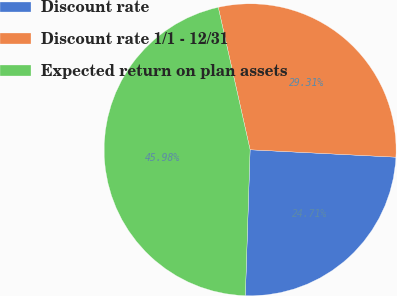Convert chart to OTSL. <chart><loc_0><loc_0><loc_500><loc_500><pie_chart><fcel>Discount rate<fcel>Discount rate 1/1 - 12/31<fcel>Expected return on plan assets<nl><fcel>24.71%<fcel>29.31%<fcel>45.98%<nl></chart> 